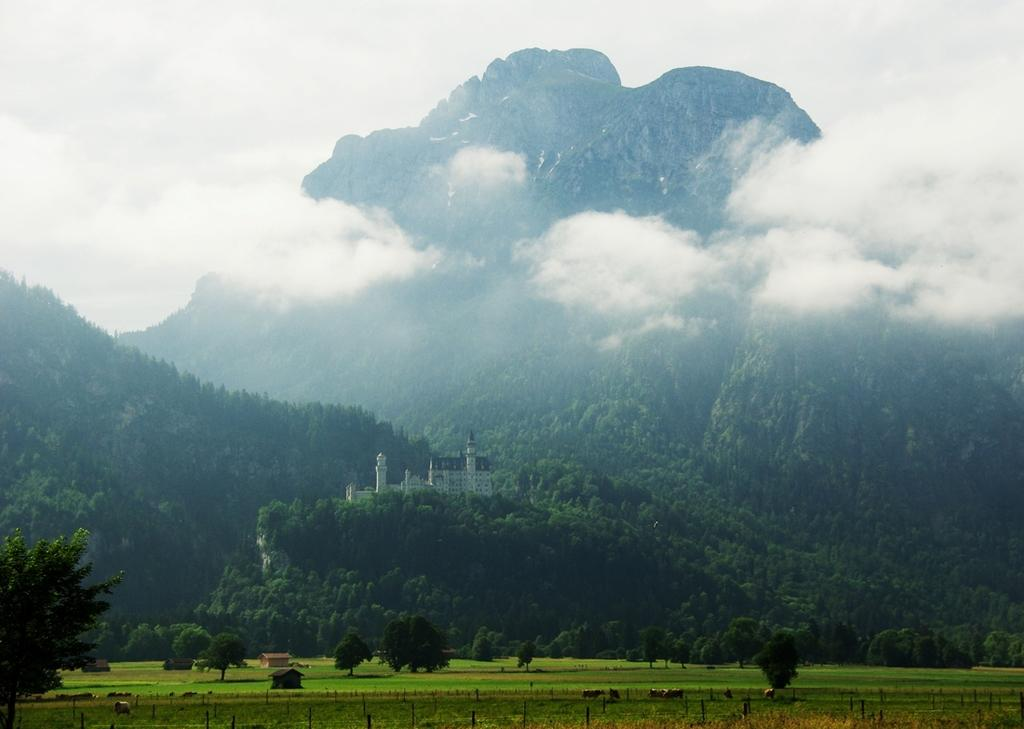What type of vegetation is present in the image? There is grass in the image. What other natural elements can be seen in the image? There are trees in the image. Are there any man-made structures visible? Yes, there is a building in the image. What type of terrain is depicted in the image? There are hills in the image. What is visible at the top of the image? The sky is visible at the top of the image. What can be observed in the sky? Clouds are present in the sky. Can you tell me how many donkeys are grazing on the grass in the image? There are no donkeys present in the image; it features grass, trees, a building, hills, and a sky with clouds. What type of bread is being used to create the clouds in the image? There is no bread present in the image, and the clouds are natural formations in the sky. 